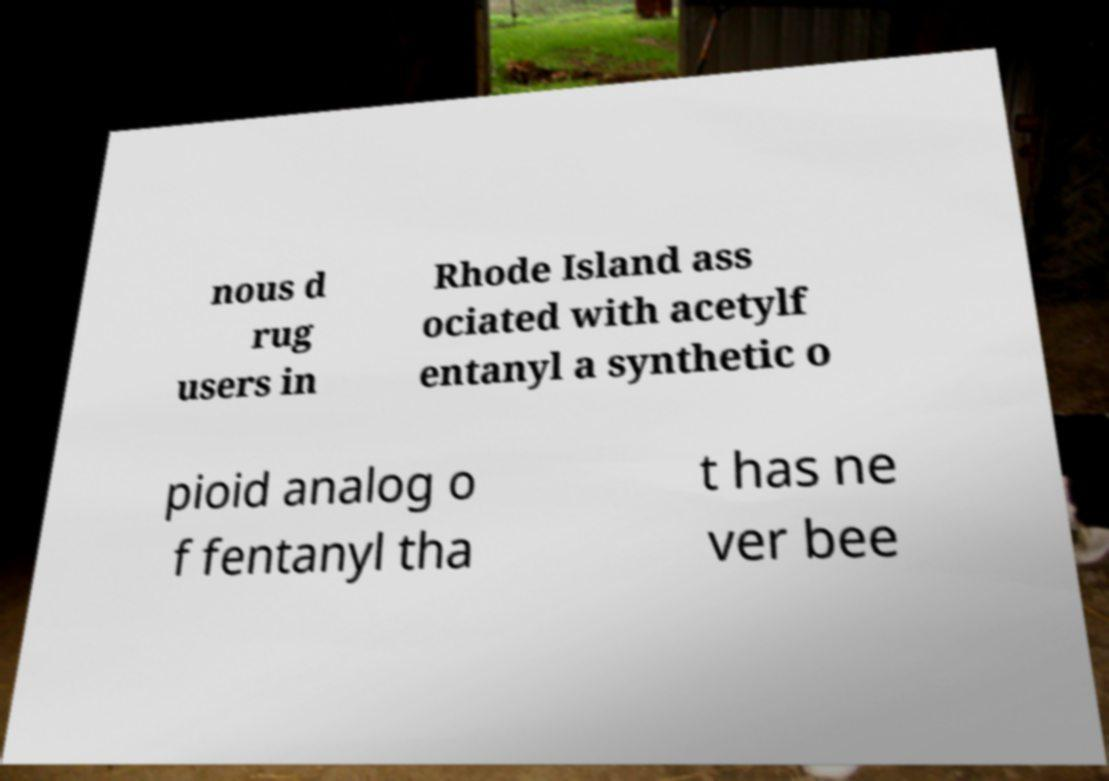For documentation purposes, I need the text within this image transcribed. Could you provide that? nous d rug users in Rhode Island ass ociated with acetylf entanyl a synthetic o pioid analog o f fentanyl tha t has ne ver bee 